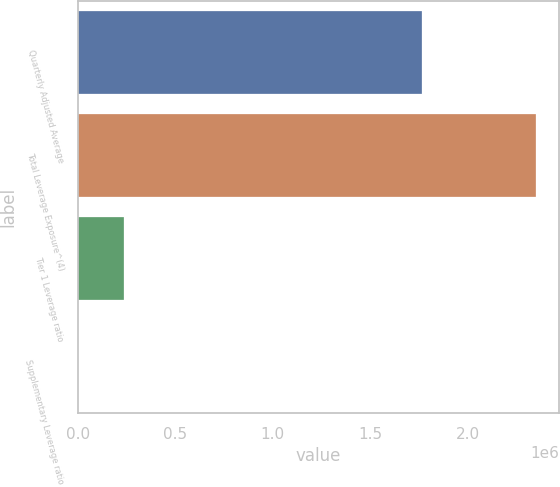<chart> <loc_0><loc_0><loc_500><loc_500><bar_chart><fcel>Quarterly Adjusted Average<fcel>Total Leverage Exposure^(4)<fcel>Tier 1 Leverage ratio<fcel>Supplementary Leverage ratio<nl><fcel>1.76842e+06<fcel>2.35188e+06<fcel>235195<fcel>7.58<nl></chart> 